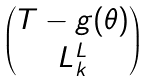<formula> <loc_0><loc_0><loc_500><loc_500>\begin{pmatrix} T - g ( \theta ) \\ L ^ { L } _ { k } \end{pmatrix}</formula> 